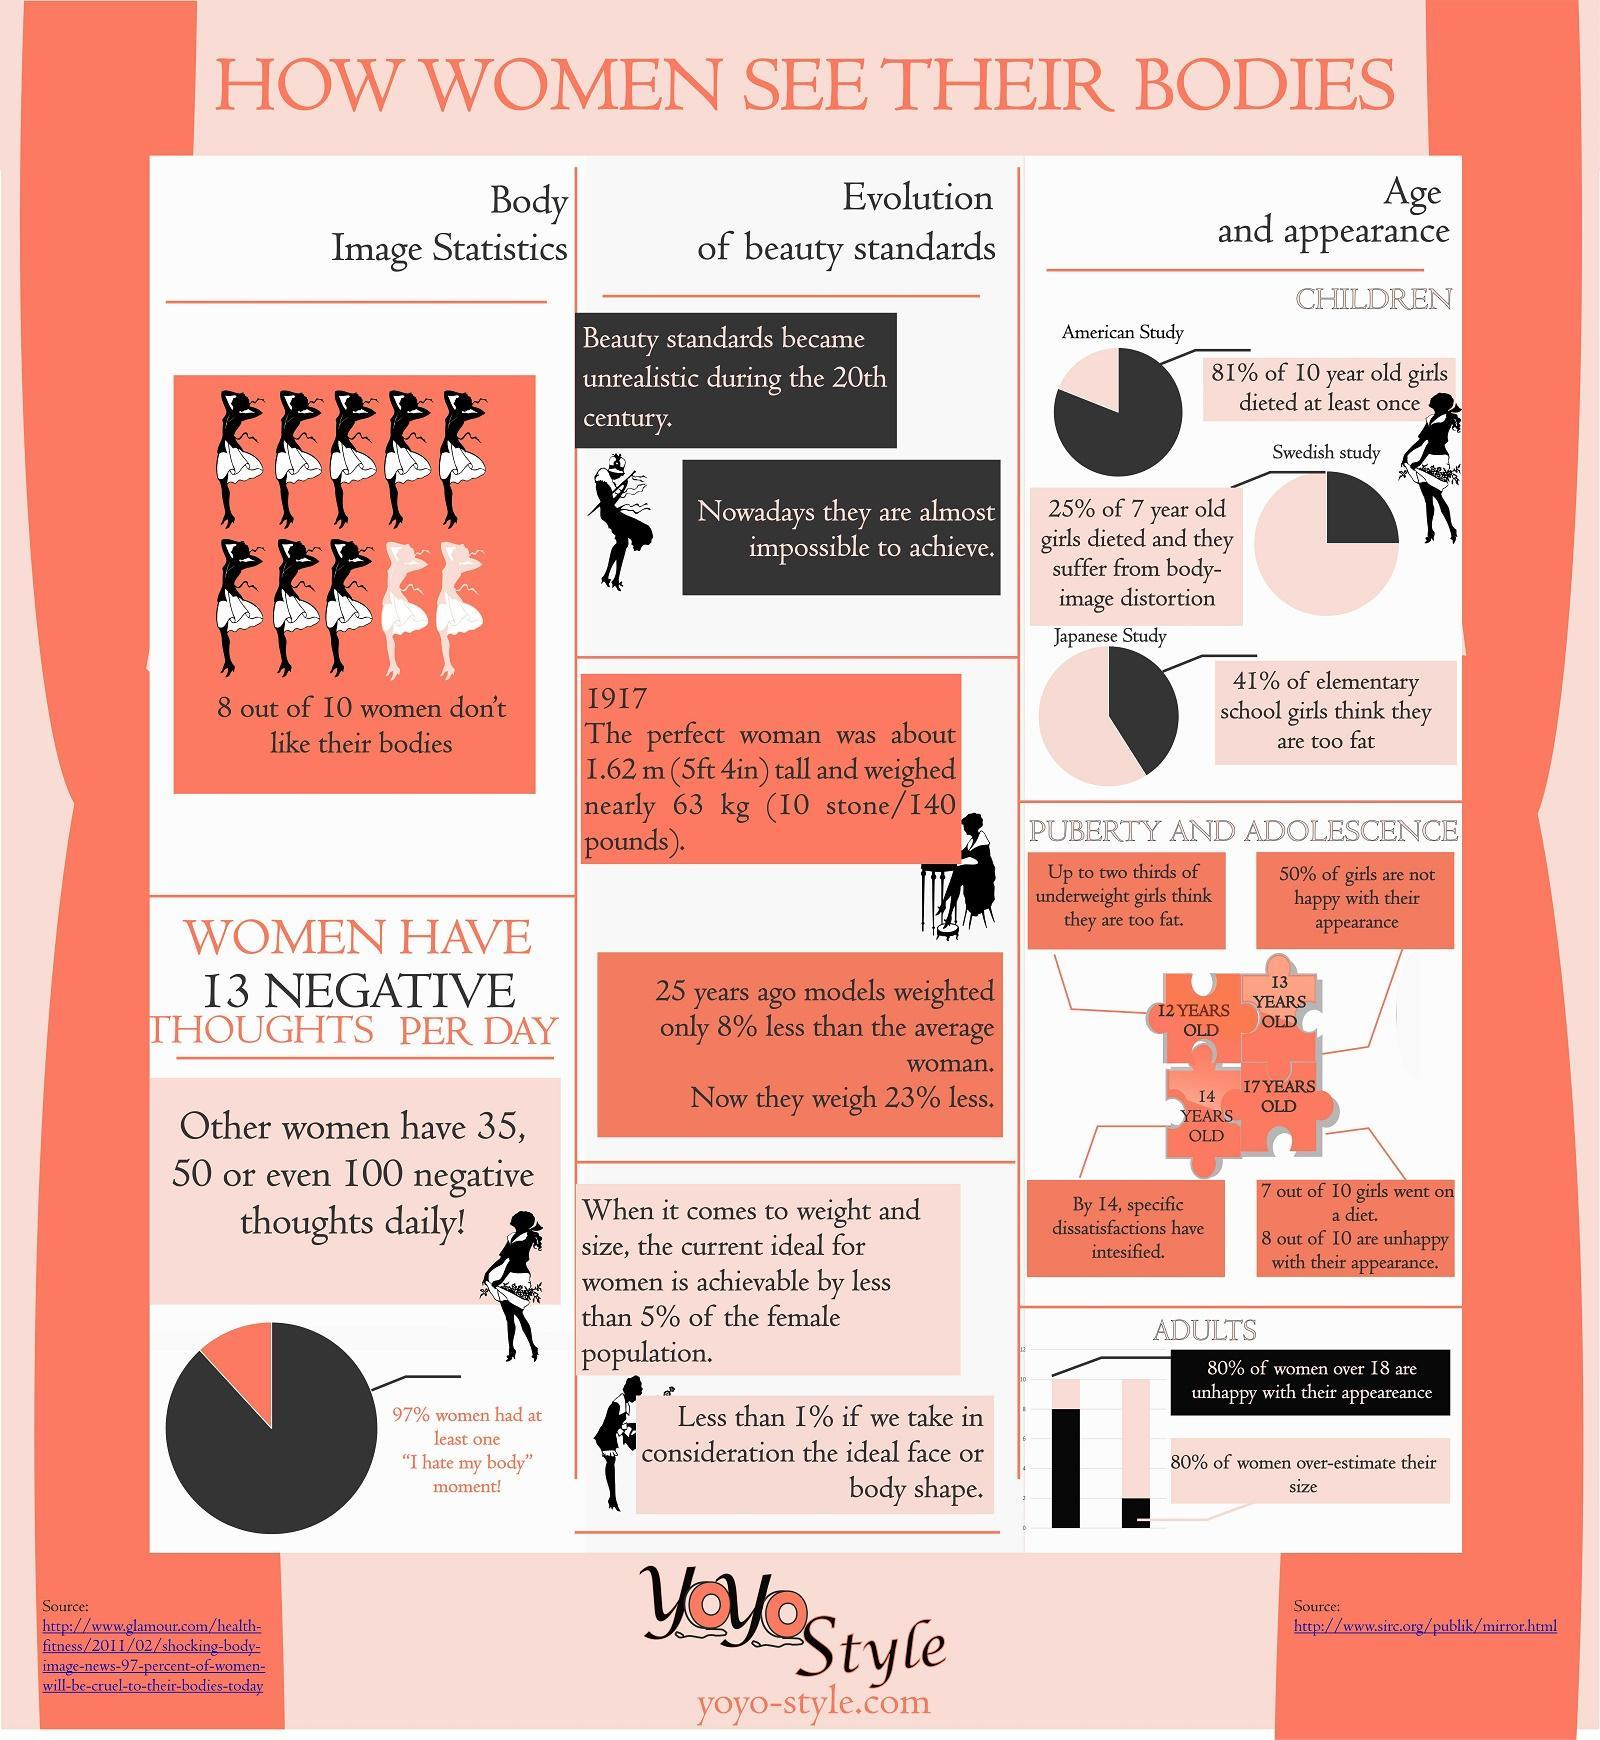Which country had 75% of non-dieting girls in the age group of seven , America, Sweden, or Japan?
Answer the question with a short phrase. Sweden Which age group has about half the girls being satisfied with their looks ? 13 YEARS OLD Which study had 59% percent of girls who did not feel they were too fat? Japanese Study What percentage of 12 year old's think they are too fat? 66.67% 